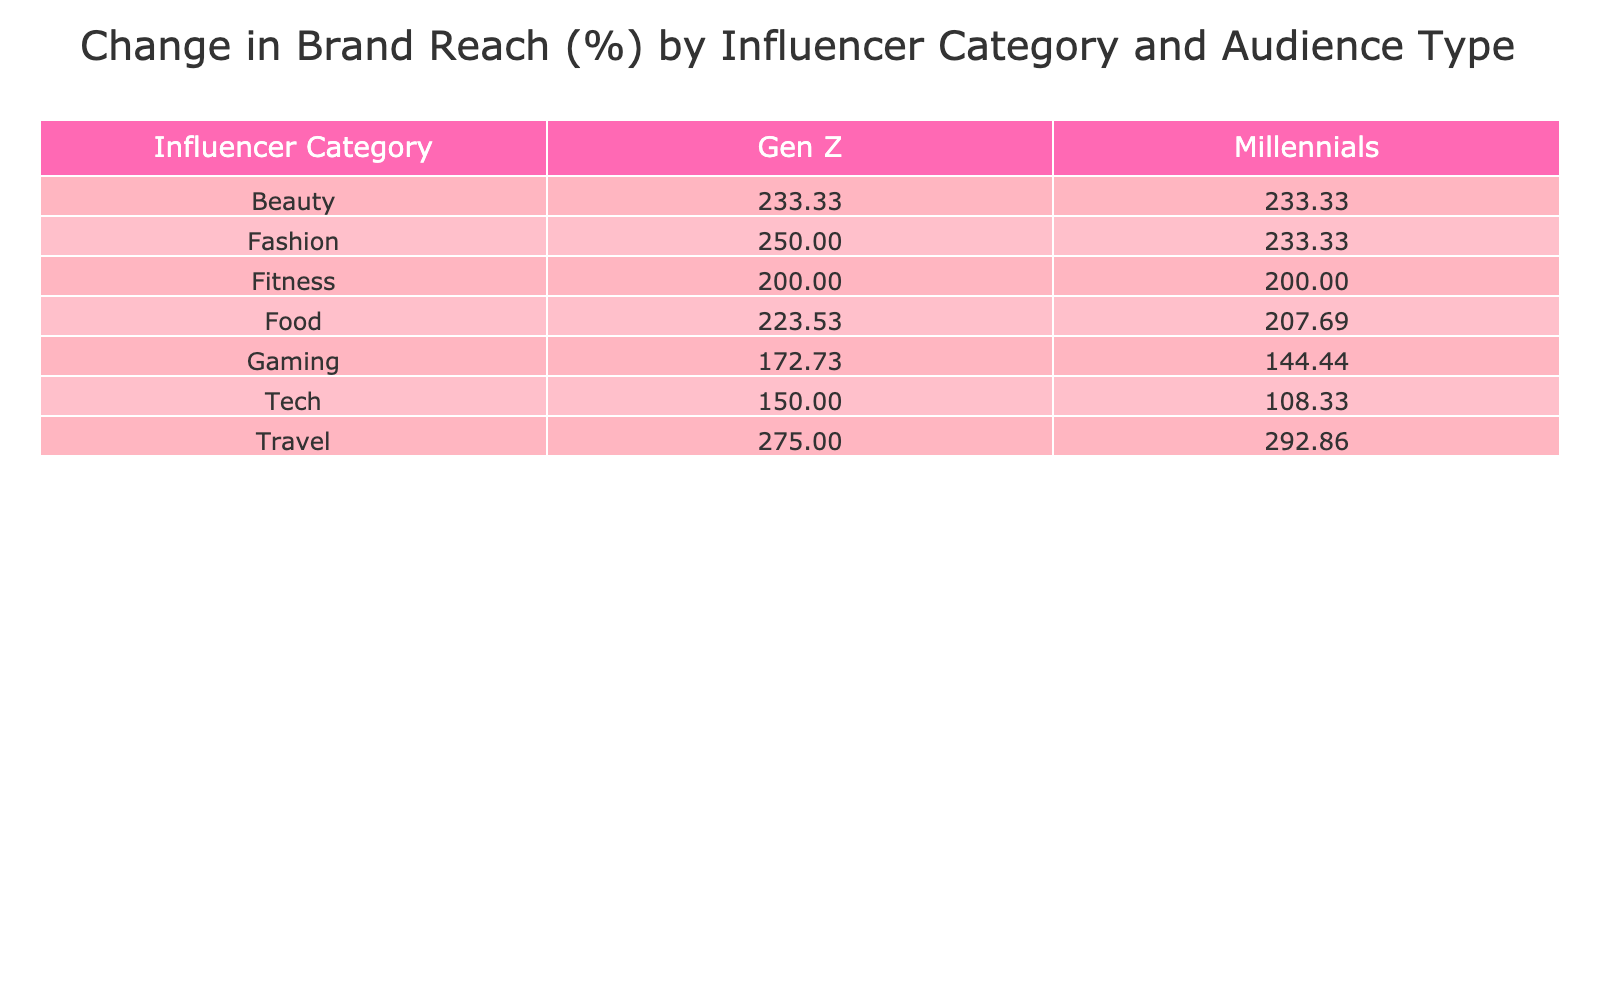What is the change in brand reach for the Beauty category among Gen Z? The table shows a change in reach for the Beauty category under Gen Z of 233.33%.
Answer: 233.33% Which influencer category had the highest increase in brand reach among Millennials? Looking at the table, the Travel category had a 292.86% increase, which is higher than any other category for Millennials.
Answer: Travel Is the change in reach for Tech influencers higher for Millennials than for Gen Z? By comparing the values in the table, Tech influencers had a 108.33% increase for Millennials and 150.00% for Gen Z. Therefore, the change for Millennials is not higher than for Gen Z.
Answer: No What is the average change in reach across all influencer categories for Millennials? First, we sum the percentage changes for Millennials: 233.33 + 233.33 + 200.00 + 108.33 + 292.86 + 144.44 + 207.69 = 1,419.98. Then we divide by the number of influencer categories (7). Therefore, the average is 1,419.98 / 7 ≈ 202.86%.
Answer: 202.86% Which two audience types experienced the same percentage change in reach for the Fitness category? The table indicates that both Millennials and Gen Z had a 200.00% increase in reach under the Fitness category. This implies that both audience types experienced the same change in percentage.
Answer: Millennials and Gen Z 